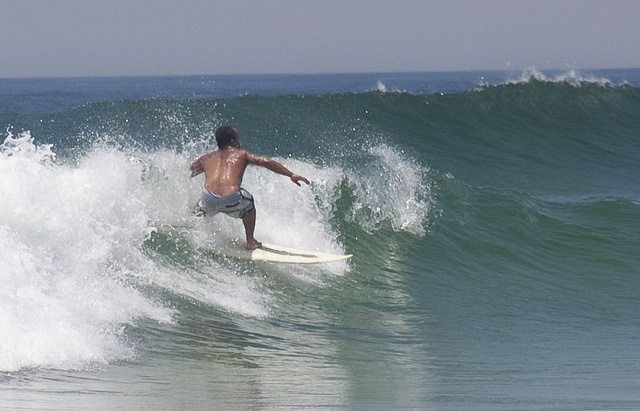Describe the objects in this image and their specific colors. I can see people in darkgray, gray, and black tones and surfboard in darkgray, ivory, gray, and lightgray tones in this image. 